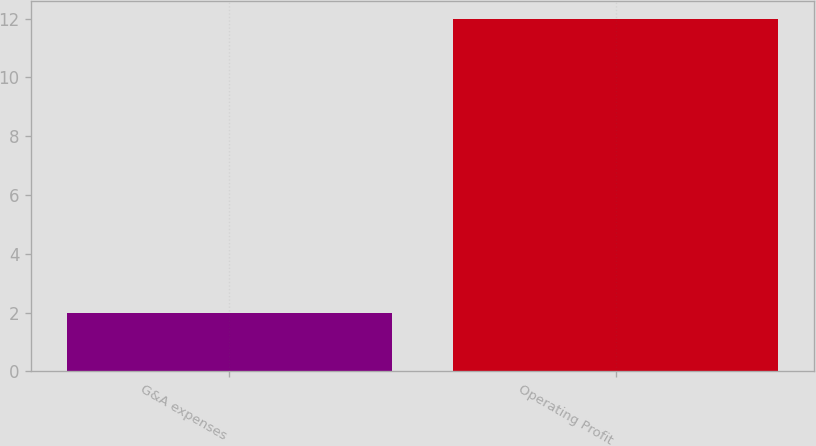Convert chart to OTSL. <chart><loc_0><loc_0><loc_500><loc_500><bar_chart><fcel>G&A expenses<fcel>Operating Profit<nl><fcel>2<fcel>12<nl></chart> 